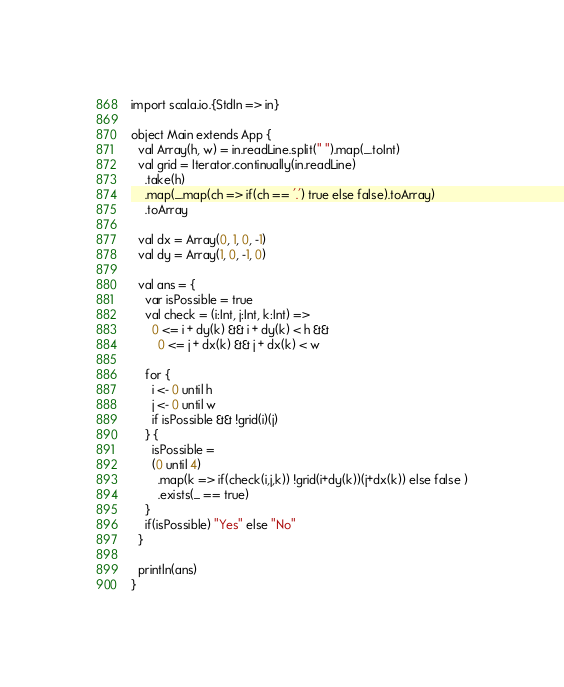<code> <loc_0><loc_0><loc_500><loc_500><_Scala_>import scala.io.{StdIn => in}

object Main extends App {
  val Array(h, w) = in.readLine.split(" ").map(_.toInt)
  val grid = Iterator.continually(in.readLine)
    .take(h)
    .map(_.map(ch => if(ch == '.') true else false).toArray)
    .toArray
  
  val dx = Array(0, 1, 0, -1)
  val dy = Array(1, 0, -1, 0)

  val ans = {
    var isPossible = true
    val check = (i:Int, j:Int, k:Int) =>
      0 <= i + dy(k) && i + dy(k) < h &&
        0 <= j + dx(k) && j + dx(k) < w

    for {
      i <- 0 until h
      j <- 0 until w
      if isPossible && !grid(i)(j)
    } {
      isPossible = 
      (0 until 4)
        .map(k => if(check(i,j,k)) !grid(i+dy(k))(j+dx(k)) else false )
        .exists(_ == true)
    }
    if(isPossible) "Yes" else "No"
  }

  println(ans)
}</code> 